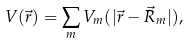<formula> <loc_0><loc_0><loc_500><loc_500>V ( \vec { r } ) = \sum _ { m } V _ { m } ( | \vec { r } - \vec { R } _ { m } | ) ,</formula> 